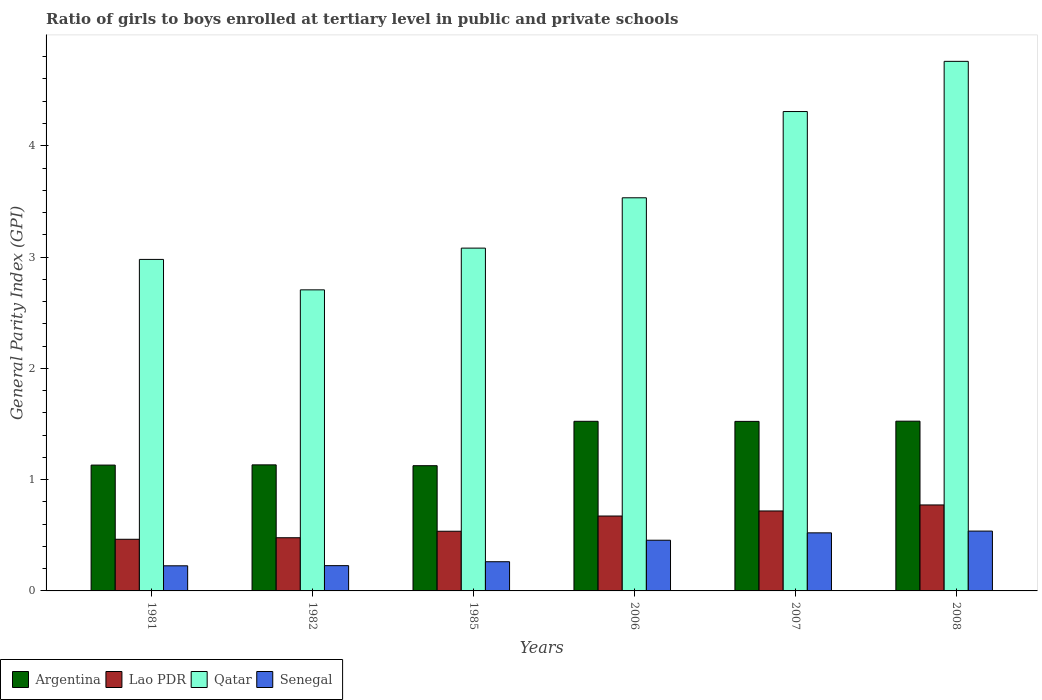How many groups of bars are there?
Your response must be concise. 6. Are the number of bars per tick equal to the number of legend labels?
Make the answer very short. Yes. In how many cases, is the number of bars for a given year not equal to the number of legend labels?
Your response must be concise. 0. What is the general parity index in Lao PDR in 1981?
Keep it short and to the point. 0.46. Across all years, what is the maximum general parity index in Qatar?
Give a very brief answer. 4.76. Across all years, what is the minimum general parity index in Argentina?
Provide a short and direct response. 1.13. In which year was the general parity index in Senegal minimum?
Give a very brief answer. 1981. What is the total general parity index in Lao PDR in the graph?
Provide a short and direct response. 3.64. What is the difference between the general parity index in Lao PDR in 1981 and that in 1985?
Your answer should be very brief. -0.07. What is the difference between the general parity index in Senegal in 1981 and the general parity index in Lao PDR in 1985?
Ensure brevity in your answer.  -0.31. What is the average general parity index in Qatar per year?
Your answer should be compact. 3.56. In the year 1985, what is the difference between the general parity index in Lao PDR and general parity index in Senegal?
Your response must be concise. 0.27. In how many years, is the general parity index in Senegal greater than 3?
Offer a very short reply. 0. What is the ratio of the general parity index in Argentina in 1981 to that in 2006?
Offer a terse response. 0.74. Is the general parity index in Senegal in 1982 less than that in 1985?
Provide a succinct answer. Yes. What is the difference between the highest and the second highest general parity index in Senegal?
Give a very brief answer. 0.02. What is the difference between the highest and the lowest general parity index in Lao PDR?
Offer a terse response. 0.31. In how many years, is the general parity index in Qatar greater than the average general parity index in Qatar taken over all years?
Your response must be concise. 2. Is the sum of the general parity index in Lao PDR in 2007 and 2008 greater than the maximum general parity index in Senegal across all years?
Give a very brief answer. Yes. Is it the case that in every year, the sum of the general parity index in Senegal and general parity index in Lao PDR is greater than the sum of general parity index in Qatar and general parity index in Argentina?
Your answer should be very brief. No. What does the 2nd bar from the left in 1981 represents?
Keep it short and to the point. Lao PDR. What does the 3rd bar from the right in 1982 represents?
Give a very brief answer. Lao PDR. How many years are there in the graph?
Keep it short and to the point. 6. Does the graph contain any zero values?
Keep it short and to the point. No. Does the graph contain grids?
Make the answer very short. No. Where does the legend appear in the graph?
Provide a succinct answer. Bottom left. What is the title of the graph?
Give a very brief answer. Ratio of girls to boys enrolled at tertiary level in public and private schools. Does "Myanmar" appear as one of the legend labels in the graph?
Offer a terse response. No. What is the label or title of the X-axis?
Ensure brevity in your answer.  Years. What is the label or title of the Y-axis?
Your answer should be very brief. General Parity Index (GPI). What is the General Parity Index (GPI) in Argentina in 1981?
Provide a short and direct response. 1.13. What is the General Parity Index (GPI) of Lao PDR in 1981?
Provide a short and direct response. 0.46. What is the General Parity Index (GPI) of Qatar in 1981?
Make the answer very short. 2.98. What is the General Parity Index (GPI) in Senegal in 1981?
Ensure brevity in your answer.  0.23. What is the General Parity Index (GPI) in Argentina in 1982?
Provide a short and direct response. 1.13. What is the General Parity Index (GPI) of Lao PDR in 1982?
Your response must be concise. 0.48. What is the General Parity Index (GPI) of Qatar in 1982?
Ensure brevity in your answer.  2.71. What is the General Parity Index (GPI) of Senegal in 1982?
Give a very brief answer. 0.23. What is the General Parity Index (GPI) in Argentina in 1985?
Keep it short and to the point. 1.13. What is the General Parity Index (GPI) in Lao PDR in 1985?
Make the answer very short. 0.54. What is the General Parity Index (GPI) of Qatar in 1985?
Make the answer very short. 3.08. What is the General Parity Index (GPI) of Senegal in 1985?
Give a very brief answer. 0.26. What is the General Parity Index (GPI) of Argentina in 2006?
Make the answer very short. 1.52. What is the General Parity Index (GPI) of Lao PDR in 2006?
Offer a terse response. 0.67. What is the General Parity Index (GPI) of Qatar in 2006?
Your answer should be compact. 3.53. What is the General Parity Index (GPI) of Senegal in 2006?
Make the answer very short. 0.46. What is the General Parity Index (GPI) in Argentina in 2007?
Give a very brief answer. 1.52. What is the General Parity Index (GPI) in Lao PDR in 2007?
Offer a very short reply. 0.72. What is the General Parity Index (GPI) in Qatar in 2007?
Ensure brevity in your answer.  4.31. What is the General Parity Index (GPI) in Senegal in 2007?
Offer a very short reply. 0.52. What is the General Parity Index (GPI) of Argentina in 2008?
Offer a terse response. 1.53. What is the General Parity Index (GPI) of Lao PDR in 2008?
Make the answer very short. 0.77. What is the General Parity Index (GPI) of Qatar in 2008?
Offer a terse response. 4.76. What is the General Parity Index (GPI) of Senegal in 2008?
Your answer should be very brief. 0.54. Across all years, what is the maximum General Parity Index (GPI) in Argentina?
Your answer should be very brief. 1.53. Across all years, what is the maximum General Parity Index (GPI) in Lao PDR?
Keep it short and to the point. 0.77. Across all years, what is the maximum General Parity Index (GPI) of Qatar?
Offer a very short reply. 4.76. Across all years, what is the maximum General Parity Index (GPI) of Senegal?
Your answer should be compact. 0.54. Across all years, what is the minimum General Parity Index (GPI) of Argentina?
Your answer should be very brief. 1.13. Across all years, what is the minimum General Parity Index (GPI) of Lao PDR?
Your response must be concise. 0.46. Across all years, what is the minimum General Parity Index (GPI) of Qatar?
Provide a succinct answer. 2.71. Across all years, what is the minimum General Parity Index (GPI) of Senegal?
Offer a very short reply. 0.23. What is the total General Parity Index (GPI) in Argentina in the graph?
Provide a short and direct response. 7.96. What is the total General Parity Index (GPI) in Lao PDR in the graph?
Give a very brief answer. 3.64. What is the total General Parity Index (GPI) in Qatar in the graph?
Your answer should be compact. 21.36. What is the total General Parity Index (GPI) of Senegal in the graph?
Offer a very short reply. 2.23. What is the difference between the General Parity Index (GPI) of Argentina in 1981 and that in 1982?
Your answer should be very brief. -0. What is the difference between the General Parity Index (GPI) of Lao PDR in 1981 and that in 1982?
Provide a short and direct response. -0.01. What is the difference between the General Parity Index (GPI) of Qatar in 1981 and that in 1982?
Offer a terse response. 0.27. What is the difference between the General Parity Index (GPI) in Senegal in 1981 and that in 1982?
Keep it short and to the point. -0. What is the difference between the General Parity Index (GPI) of Argentina in 1981 and that in 1985?
Give a very brief answer. 0.01. What is the difference between the General Parity Index (GPI) of Lao PDR in 1981 and that in 1985?
Your answer should be compact. -0.07. What is the difference between the General Parity Index (GPI) in Qatar in 1981 and that in 1985?
Make the answer very short. -0.1. What is the difference between the General Parity Index (GPI) of Senegal in 1981 and that in 1985?
Make the answer very short. -0.04. What is the difference between the General Parity Index (GPI) of Argentina in 1981 and that in 2006?
Ensure brevity in your answer.  -0.39. What is the difference between the General Parity Index (GPI) in Lao PDR in 1981 and that in 2006?
Offer a terse response. -0.21. What is the difference between the General Parity Index (GPI) in Qatar in 1981 and that in 2006?
Your response must be concise. -0.55. What is the difference between the General Parity Index (GPI) of Senegal in 1981 and that in 2006?
Give a very brief answer. -0.23. What is the difference between the General Parity Index (GPI) in Argentina in 1981 and that in 2007?
Your answer should be very brief. -0.39. What is the difference between the General Parity Index (GPI) in Lao PDR in 1981 and that in 2007?
Make the answer very short. -0.25. What is the difference between the General Parity Index (GPI) of Qatar in 1981 and that in 2007?
Ensure brevity in your answer.  -1.33. What is the difference between the General Parity Index (GPI) of Senegal in 1981 and that in 2007?
Keep it short and to the point. -0.3. What is the difference between the General Parity Index (GPI) of Argentina in 1981 and that in 2008?
Give a very brief answer. -0.39. What is the difference between the General Parity Index (GPI) in Lao PDR in 1981 and that in 2008?
Offer a very short reply. -0.31. What is the difference between the General Parity Index (GPI) in Qatar in 1981 and that in 2008?
Give a very brief answer. -1.78. What is the difference between the General Parity Index (GPI) of Senegal in 1981 and that in 2008?
Offer a very short reply. -0.31. What is the difference between the General Parity Index (GPI) of Argentina in 1982 and that in 1985?
Your answer should be very brief. 0.01. What is the difference between the General Parity Index (GPI) of Lao PDR in 1982 and that in 1985?
Make the answer very short. -0.06. What is the difference between the General Parity Index (GPI) of Qatar in 1982 and that in 1985?
Offer a very short reply. -0.38. What is the difference between the General Parity Index (GPI) of Senegal in 1982 and that in 1985?
Ensure brevity in your answer.  -0.04. What is the difference between the General Parity Index (GPI) in Argentina in 1982 and that in 2006?
Make the answer very short. -0.39. What is the difference between the General Parity Index (GPI) of Lao PDR in 1982 and that in 2006?
Provide a short and direct response. -0.2. What is the difference between the General Parity Index (GPI) of Qatar in 1982 and that in 2006?
Your answer should be very brief. -0.83. What is the difference between the General Parity Index (GPI) of Senegal in 1982 and that in 2006?
Ensure brevity in your answer.  -0.23. What is the difference between the General Parity Index (GPI) of Argentina in 1982 and that in 2007?
Provide a succinct answer. -0.39. What is the difference between the General Parity Index (GPI) in Lao PDR in 1982 and that in 2007?
Offer a very short reply. -0.24. What is the difference between the General Parity Index (GPI) in Qatar in 1982 and that in 2007?
Provide a short and direct response. -1.6. What is the difference between the General Parity Index (GPI) in Senegal in 1982 and that in 2007?
Keep it short and to the point. -0.29. What is the difference between the General Parity Index (GPI) in Argentina in 1982 and that in 2008?
Make the answer very short. -0.39. What is the difference between the General Parity Index (GPI) of Lao PDR in 1982 and that in 2008?
Your answer should be compact. -0.29. What is the difference between the General Parity Index (GPI) in Qatar in 1982 and that in 2008?
Provide a succinct answer. -2.05. What is the difference between the General Parity Index (GPI) of Senegal in 1982 and that in 2008?
Offer a terse response. -0.31. What is the difference between the General Parity Index (GPI) of Argentina in 1985 and that in 2006?
Make the answer very short. -0.4. What is the difference between the General Parity Index (GPI) in Lao PDR in 1985 and that in 2006?
Offer a terse response. -0.14. What is the difference between the General Parity Index (GPI) of Qatar in 1985 and that in 2006?
Provide a short and direct response. -0.45. What is the difference between the General Parity Index (GPI) in Senegal in 1985 and that in 2006?
Your answer should be compact. -0.19. What is the difference between the General Parity Index (GPI) of Argentina in 1985 and that in 2007?
Your answer should be compact. -0.4. What is the difference between the General Parity Index (GPI) of Lao PDR in 1985 and that in 2007?
Provide a short and direct response. -0.18. What is the difference between the General Parity Index (GPI) of Qatar in 1985 and that in 2007?
Provide a succinct answer. -1.23. What is the difference between the General Parity Index (GPI) of Senegal in 1985 and that in 2007?
Make the answer very short. -0.26. What is the difference between the General Parity Index (GPI) in Argentina in 1985 and that in 2008?
Provide a short and direct response. -0.4. What is the difference between the General Parity Index (GPI) of Lao PDR in 1985 and that in 2008?
Offer a very short reply. -0.24. What is the difference between the General Parity Index (GPI) in Qatar in 1985 and that in 2008?
Make the answer very short. -1.68. What is the difference between the General Parity Index (GPI) in Senegal in 1985 and that in 2008?
Your response must be concise. -0.28. What is the difference between the General Parity Index (GPI) of Argentina in 2006 and that in 2007?
Your answer should be compact. 0. What is the difference between the General Parity Index (GPI) of Lao PDR in 2006 and that in 2007?
Ensure brevity in your answer.  -0.05. What is the difference between the General Parity Index (GPI) in Qatar in 2006 and that in 2007?
Offer a terse response. -0.77. What is the difference between the General Parity Index (GPI) in Senegal in 2006 and that in 2007?
Provide a short and direct response. -0.07. What is the difference between the General Parity Index (GPI) of Argentina in 2006 and that in 2008?
Give a very brief answer. -0. What is the difference between the General Parity Index (GPI) in Lao PDR in 2006 and that in 2008?
Your response must be concise. -0.1. What is the difference between the General Parity Index (GPI) of Qatar in 2006 and that in 2008?
Ensure brevity in your answer.  -1.23. What is the difference between the General Parity Index (GPI) in Senegal in 2006 and that in 2008?
Provide a short and direct response. -0.08. What is the difference between the General Parity Index (GPI) in Argentina in 2007 and that in 2008?
Keep it short and to the point. -0. What is the difference between the General Parity Index (GPI) in Lao PDR in 2007 and that in 2008?
Offer a terse response. -0.05. What is the difference between the General Parity Index (GPI) of Qatar in 2007 and that in 2008?
Ensure brevity in your answer.  -0.45. What is the difference between the General Parity Index (GPI) of Senegal in 2007 and that in 2008?
Your answer should be compact. -0.02. What is the difference between the General Parity Index (GPI) of Argentina in 1981 and the General Parity Index (GPI) of Lao PDR in 1982?
Your answer should be very brief. 0.65. What is the difference between the General Parity Index (GPI) of Argentina in 1981 and the General Parity Index (GPI) of Qatar in 1982?
Your answer should be very brief. -1.57. What is the difference between the General Parity Index (GPI) in Argentina in 1981 and the General Parity Index (GPI) in Senegal in 1982?
Your answer should be compact. 0.9. What is the difference between the General Parity Index (GPI) in Lao PDR in 1981 and the General Parity Index (GPI) in Qatar in 1982?
Make the answer very short. -2.24. What is the difference between the General Parity Index (GPI) of Lao PDR in 1981 and the General Parity Index (GPI) of Senegal in 1982?
Offer a terse response. 0.24. What is the difference between the General Parity Index (GPI) in Qatar in 1981 and the General Parity Index (GPI) in Senegal in 1982?
Provide a succinct answer. 2.75. What is the difference between the General Parity Index (GPI) in Argentina in 1981 and the General Parity Index (GPI) in Lao PDR in 1985?
Your answer should be compact. 0.59. What is the difference between the General Parity Index (GPI) in Argentina in 1981 and the General Parity Index (GPI) in Qatar in 1985?
Your answer should be very brief. -1.95. What is the difference between the General Parity Index (GPI) of Argentina in 1981 and the General Parity Index (GPI) of Senegal in 1985?
Your response must be concise. 0.87. What is the difference between the General Parity Index (GPI) of Lao PDR in 1981 and the General Parity Index (GPI) of Qatar in 1985?
Offer a terse response. -2.62. What is the difference between the General Parity Index (GPI) in Lao PDR in 1981 and the General Parity Index (GPI) in Senegal in 1985?
Provide a succinct answer. 0.2. What is the difference between the General Parity Index (GPI) of Qatar in 1981 and the General Parity Index (GPI) of Senegal in 1985?
Offer a very short reply. 2.72. What is the difference between the General Parity Index (GPI) in Argentina in 1981 and the General Parity Index (GPI) in Lao PDR in 2006?
Your answer should be compact. 0.46. What is the difference between the General Parity Index (GPI) in Argentina in 1981 and the General Parity Index (GPI) in Qatar in 2006?
Provide a succinct answer. -2.4. What is the difference between the General Parity Index (GPI) of Argentina in 1981 and the General Parity Index (GPI) of Senegal in 2006?
Offer a very short reply. 0.68. What is the difference between the General Parity Index (GPI) in Lao PDR in 1981 and the General Parity Index (GPI) in Qatar in 2006?
Your answer should be very brief. -3.07. What is the difference between the General Parity Index (GPI) of Lao PDR in 1981 and the General Parity Index (GPI) of Senegal in 2006?
Your response must be concise. 0.01. What is the difference between the General Parity Index (GPI) in Qatar in 1981 and the General Parity Index (GPI) in Senegal in 2006?
Provide a short and direct response. 2.52. What is the difference between the General Parity Index (GPI) of Argentina in 1981 and the General Parity Index (GPI) of Lao PDR in 2007?
Provide a succinct answer. 0.41. What is the difference between the General Parity Index (GPI) of Argentina in 1981 and the General Parity Index (GPI) of Qatar in 2007?
Offer a terse response. -3.18. What is the difference between the General Parity Index (GPI) in Argentina in 1981 and the General Parity Index (GPI) in Senegal in 2007?
Offer a terse response. 0.61. What is the difference between the General Parity Index (GPI) of Lao PDR in 1981 and the General Parity Index (GPI) of Qatar in 2007?
Your answer should be very brief. -3.84. What is the difference between the General Parity Index (GPI) of Lao PDR in 1981 and the General Parity Index (GPI) of Senegal in 2007?
Your response must be concise. -0.06. What is the difference between the General Parity Index (GPI) of Qatar in 1981 and the General Parity Index (GPI) of Senegal in 2007?
Offer a terse response. 2.46. What is the difference between the General Parity Index (GPI) in Argentina in 1981 and the General Parity Index (GPI) in Lao PDR in 2008?
Ensure brevity in your answer.  0.36. What is the difference between the General Parity Index (GPI) of Argentina in 1981 and the General Parity Index (GPI) of Qatar in 2008?
Your answer should be very brief. -3.63. What is the difference between the General Parity Index (GPI) in Argentina in 1981 and the General Parity Index (GPI) in Senegal in 2008?
Provide a succinct answer. 0.59. What is the difference between the General Parity Index (GPI) in Lao PDR in 1981 and the General Parity Index (GPI) in Qatar in 2008?
Your response must be concise. -4.29. What is the difference between the General Parity Index (GPI) of Lao PDR in 1981 and the General Parity Index (GPI) of Senegal in 2008?
Provide a short and direct response. -0.07. What is the difference between the General Parity Index (GPI) of Qatar in 1981 and the General Parity Index (GPI) of Senegal in 2008?
Ensure brevity in your answer.  2.44. What is the difference between the General Parity Index (GPI) of Argentina in 1982 and the General Parity Index (GPI) of Lao PDR in 1985?
Your answer should be compact. 0.6. What is the difference between the General Parity Index (GPI) in Argentina in 1982 and the General Parity Index (GPI) in Qatar in 1985?
Your answer should be compact. -1.95. What is the difference between the General Parity Index (GPI) of Argentina in 1982 and the General Parity Index (GPI) of Senegal in 1985?
Your answer should be very brief. 0.87. What is the difference between the General Parity Index (GPI) in Lao PDR in 1982 and the General Parity Index (GPI) in Qatar in 1985?
Give a very brief answer. -2.6. What is the difference between the General Parity Index (GPI) of Lao PDR in 1982 and the General Parity Index (GPI) of Senegal in 1985?
Your answer should be compact. 0.22. What is the difference between the General Parity Index (GPI) in Qatar in 1982 and the General Parity Index (GPI) in Senegal in 1985?
Your answer should be compact. 2.44. What is the difference between the General Parity Index (GPI) of Argentina in 1982 and the General Parity Index (GPI) of Lao PDR in 2006?
Keep it short and to the point. 0.46. What is the difference between the General Parity Index (GPI) in Argentina in 1982 and the General Parity Index (GPI) in Qatar in 2006?
Provide a short and direct response. -2.4. What is the difference between the General Parity Index (GPI) of Argentina in 1982 and the General Parity Index (GPI) of Senegal in 2006?
Your response must be concise. 0.68. What is the difference between the General Parity Index (GPI) in Lao PDR in 1982 and the General Parity Index (GPI) in Qatar in 2006?
Make the answer very short. -3.05. What is the difference between the General Parity Index (GPI) in Lao PDR in 1982 and the General Parity Index (GPI) in Senegal in 2006?
Provide a short and direct response. 0.02. What is the difference between the General Parity Index (GPI) of Qatar in 1982 and the General Parity Index (GPI) of Senegal in 2006?
Offer a very short reply. 2.25. What is the difference between the General Parity Index (GPI) in Argentina in 1982 and the General Parity Index (GPI) in Lao PDR in 2007?
Provide a succinct answer. 0.41. What is the difference between the General Parity Index (GPI) in Argentina in 1982 and the General Parity Index (GPI) in Qatar in 2007?
Offer a very short reply. -3.17. What is the difference between the General Parity Index (GPI) in Argentina in 1982 and the General Parity Index (GPI) in Senegal in 2007?
Your response must be concise. 0.61. What is the difference between the General Parity Index (GPI) of Lao PDR in 1982 and the General Parity Index (GPI) of Qatar in 2007?
Give a very brief answer. -3.83. What is the difference between the General Parity Index (GPI) in Lao PDR in 1982 and the General Parity Index (GPI) in Senegal in 2007?
Keep it short and to the point. -0.04. What is the difference between the General Parity Index (GPI) of Qatar in 1982 and the General Parity Index (GPI) of Senegal in 2007?
Keep it short and to the point. 2.18. What is the difference between the General Parity Index (GPI) in Argentina in 1982 and the General Parity Index (GPI) in Lao PDR in 2008?
Your answer should be compact. 0.36. What is the difference between the General Parity Index (GPI) in Argentina in 1982 and the General Parity Index (GPI) in Qatar in 2008?
Offer a terse response. -3.63. What is the difference between the General Parity Index (GPI) in Argentina in 1982 and the General Parity Index (GPI) in Senegal in 2008?
Offer a very short reply. 0.6. What is the difference between the General Parity Index (GPI) in Lao PDR in 1982 and the General Parity Index (GPI) in Qatar in 2008?
Provide a short and direct response. -4.28. What is the difference between the General Parity Index (GPI) of Lao PDR in 1982 and the General Parity Index (GPI) of Senegal in 2008?
Your answer should be very brief. -0.06. What is the difference between the General Parity Index (GPI) in Qatar in 1982 and the General Parity Index (GPI) in Senegal in 2008?
Ensure brevity in your answer.  2.17. What is the difference between the General Parity Index (GPI) of Argentina in 1985 and the General Parity Index (GPI) of Lao PDR in 2006?
Offer a terse response. 0.45. What is the difference between the General Parity Index (GPI) in Argentina in 1985 and the General Parity Index (GPI) in Qatar in 2006?
Your answer should be compact. -2.41. What is the difference between the General Parity Index (GPI) of Argentina in 1985 and the General Parity Index (GPI) of Senegal in 2006?
Keep it short and to the point. 0.67. What is the difference between the General Parity Index (GPI) in Lao PDR in 1985 and the General Parity Index (GPI) in Qatar in 2006?
Keep it short and to the point. -3. What is the difference between the General Parity Index (GPI) in Lao PDR in 1985 and the General Parity Index (GPI) in Senegal in 2006?
Offer a very short reply. 0.08. What is the difference between the General Parity Index (GPI) of Qatar in 1985 and the General Parity Index (GPI) of Senegal in 2006?
Provide a short and direct response. 2.62. What is the difference between the General Parity Index (GPI) in Argentina in 1985 and the General Parity Index (GPI) in Lao PDR in 2007?
Your answer should be compact. 0.41. What is the difference between the General Parity Index (GPI) in Argentina in 1985 and the General Parity Index (GPI) in Qatar in 2007?
Your answer should be compact. -3.18. What is the difference between the General Parity Index (GPI) of Argentina in 1985 and the General Parity Index (GPI) of Senegal in 2007?
Provide a succinct answer. 0.6. What is the difference between the General Parity Index (GPI) of Lao PDR in 1985 and the General Parity Index (GPI) of Qatar in 2007?
Make the answer very short. -3.77. What is the difference between the General Parity Index (GPI) in Lao PDR in 1985 and the General Parity Index (GPI) in Senegal in 2007?
Your answer should be very brief. 0.01. What is the difference between the General Parity Index (GPI) in Qatar in 1985 and the General Parity Index (GPI) in Senegal in 2007?
Offer a very short reply. 2.56. What is the difference between the General Parity Index (GPI) in Argentina in 1985 and the General Parity Index (GPI) in Lao PDR in 2008?
Provide a short and direct response. 0.35. What is the difference between the General Parity Index (GPI) of Argentina in 1985 and the General Parity Index (GPI) of Qatar in 2008?
Offer a very short reply. -3.63. What is the difference between the General Parity Index (GPI) in Argentina in 1985 and the General Parity Index (GPI) in Senegal in 2008?
Your answer should be very brief. 0.59. What is the difference between the General Parity Index (GPI) of Lao PDR in 1985 and the General Parity Index (GPI) of Qatar in 2008?
Keep it short and to the point. -4.22. What is the difference between the General Parity Index (GPI) in Lao PDR in 1985 and the General Parity Index (GPI) in Senegal in 2008?
Your response must be concise. -0. What is the difference between the General Parity Index (GPI) of Qatar in 1985 and the General Parity Index (GPI) of Senegal in 2008?
Keep it short and to the point. 2.54. What is the difference between the General Parity Index (GPI) of Argentina in 2006 and the General Parity Index (GPI) of Lao PDR in 2007?
Give a very brief answer. 0.81. What is the difference between the General Parity Index (GPI) in Argentina in 2006 and the General Parity Index (GPI) in Qatar in 2007?
Your answer should be compact. -2.78. What is the difference between the General Parity Index (GPI) in Argentina in 2006 and the General Parity Index (GPI) in Senegal in 2007?
Offer a very short reply. 1. What is the difference between the General Parity Index (GPI) of Lao PDR in 2006 and the General Parity Index (GPI) of Qatar in 2007?
Keep it short and to the point. -3.63. What is the difference between the General Parity Index (GPI) of Lao PDR in 2006 and the General Parity Index (GPI) of Senegal in 2007?
Offer a terse response. 0.15. What is the difference between the General Parity Index (GPI) in Qatar in 2006 and the General Parity Index (GPI) in Senegal in 2007?
Offer a terse response. 3.01. What is the difference between the General Parity Index (GPI) of Argentina in 2006 and the General Parity Index (GPI) of Lao PDR in 2008?
Offer a very short reply. 0.75. What is the difference between the General Parity Index (GPI) of Argentina in 2006 and the General Parity Index (GPI) of Qatar in 2008?
Keep it short and to the point. -3.23. What is the difference between the General Parity Index (GPI) of Argentina in 2006 and the General Parity Index (GPI) of Senegal in 2008?
Keep it short and to the point. 0.99. What is the difference between the General Parity Index (GPI) of Lao PDR in 2006 and the General Parity Index (GPI) of Qatar in 2008?
Your response must be concise. -4.09. What is the difference between the General Parity Index (GPI) in Lao PDR in 2006 and the General Parity Index (GPI) in Senegal in 2008?
Your answer should be compact. 0.14. What is the difference between the General Parity Index (GPI) in Qatar in 2006 and the General Parity Index (GPI) in Senegal in 2008?
Make the answer very short. 2.99. What is the difference between the General Parity Index (GPI) in Argentina in 2007 and the General Parity Index (GPI) in Lao PDR in 2008?
Make the answer very short. 0.75. What is the difference between the General Parity Index (GPI) of Argentina in 2007 and the General Parity Index (GPI) of Qatar in 2008?
Give a very brief answer. -3.24. What is the difference between the General Parity Index (GPI) of Argentina in 2007 and the General Parity Index (GPI) of Senegal in 2008?
Keep it short and to the point. 0.99. What is the difference between the General Parity Index (GPI) in Lao PDR in 2007 and the General Parity Index (GPI) in Qatar in 2008?
Provide a short and direct response. -4.04. What is the difference between the General Parity Index (GPI) of Lao PDR in 2007 and the General Parity Index (GPI) of Senegal in 2008?
Your response must be concise. 0.18. What is the difference between the General Parity Index (GPI) of Qatar in 2007 and the General Parity Index (GPI) of Senegal in 2008?
Make the answer very short. 3.77. What is the average General Parity Index (GPI) in Argentina per year?
Your response must be concise. 1.33. What is the average General Parity Index (GPI) of Lao PDR per year?
Ensure brevity in your answer.  0.61. What is the average General Parity Index (GPI) of Qatar per year?
Make the answer very short. 3.56. What is the average General Parity Index (GPI) in Senegal per year?
Your answer should be very brief. 0.37. In the year 1981, what is the difference between the General Parity Index (GPI) of Argentina and General Parity Index (GPI) of Lao PDR?
Give a very brief answer. 0.67. In the year 1981, what is the difference between the General Parity Index (GPI) in Argentina and General Parity Index (GPI) in Qatar?
Your response must be concise. -1.85. In the year 1981, what is the difference between the General Parity Index (GPI) of Argentina and General Parity Index (GPI) of Senegal?
Your answer should be compact. 0.91. In the year 1981, what is the difference between the General Parity Index (GPI) of Lao PDR and General Parity Index (GPI) of Qatar?
Offer a terse response. -2.51. In the year 1981, what is the difference between the General Parity Index (GPI) in Lao PDR and General Parity Index (GPI) in Senegal?
Your response must be concise. 0.24. In the year 1981, what is the difference between the General Parity Index (GPI) in Qatar and General Parity Index (GPI) in Senegal?
Ensure brevity in your answer.  2.75. In the year 1982, what is the difference between the General Parity Index (GPI) in Argentina and General Parity Index (GPI) in Lao PDR?
Your response must be concise. 0.65. In the year 1982, what is the difference between the General Parity Index (GPI) in Argentina and General Parity Index (GPI) in Qatar?
Ensure brevity in your answer.  -1.57. In the year 1982, what is the difference between the General Parity Index (GPI) in Argentina and General Parity Index (GPI) in Senegal?
Provide a succinct answer. 0.91. In the year 1982, what is the difference between the General Parity Index (GPI) of Lao PDR and General Parity Index (GPI) of Qatar?
Offer a terse response. -2.23. In the year 1982, what is the difference between the General Parity Index (GPI) in Lao PDR and General Parity Index (GPI) in Senegal?
Give a very brief answer. 0.25. In the year 1982, what is the difference between the General Parity Index (GPI) in Qatar and General Parity Index (GPI) in Senegal?
Keep it short and to the point. 2.48. In the year 1985, what is the difference between the General Parity Index (GPI) of Argentina and General Parity Index (GPI) of Lao PDR?
Give a very brief answer. 0.59. In the year 1985, what is the difference between the General Parity Index (GPI) in Argentina and General Parity Index (GPI) in Qatar?
Offer a very short reply. -1.96. In the year 1985, what is the difference between the General Parity Index (GPI) of Argentina and General Parity Index (GPI) of Senegal?
Keep it short and to the point. 0.86. In the year 1985, what is the difference between the General Parity Index (GPI) of Lao PDR and General Parity Index (GPI) of Qatar?
Keep it short and to the point. -2.54. In the year 1985, what is the difference between the General Parity Index (GPI) of Lao PDR and General Parity Index (GPI) of Senegal?
Give a very brief answer. 0.27. In the year 1985, what is the difference between the General Parity Index (GPI) of Qatar and General Parity Index (GPI) of Senegal?
Keep it short and to the point. 2.82. In the year 2006, what is the difference between the General Parity Index (GPI) in Argentina and General Parity Index (GPI) in Lao PDR?
Provide a succinct answer. 0.85. In the year 2006, what is the difference between the General Parity Index (GPI) of Argentina and General Parity Index (GPI) of Qatar?
Your answer should be very brief. -2.01. In the year 2006, what is the difference between the General Parity Index (GPI) in Argentina and General Parity Index (GPI) in Senegal?
Provide a succinct answer. 1.07. In the year 2006, what is the difference between the General Parity Index (GPI) in Lao PDR and General Parity Index (GPI) in Qatar?
Your response must be concise. -2.86. In the year 2006, what is the difference between the General Parity Index (GPI) of Lao PDR and General Parity Index (GPI) of Senegal?
Provide a short and direct response. 0.22. In the year 2006, what is the difference between the General Parity Index (GPI) of Qatar and General Parity Index (GPI) of Senegal?
Your answer should be compact. 3.08. In the year 2007, what is the difference between the General Parity Index (GPI) in Argentina and General Parity Index (GPI) in Lao PDR?
Offer a very short reply. 0.8. In the year 2007, what is the difference between the General Parity Index (GPI) in Argentina and General Parity Index (GPI) in Qatar?
Your response must be concise. -2.78. In the year 2007, what is the difference between the General Parity Index (GPI) in Lao PDR and General Parity Index (GPI) in Qatar?
Keep it short and to the point. -3.59. In the year 2007, what is the difference between the General Parity Index (GPI) of Lao PDR and General Parity Index (GPI) of Senegal?
Your response must be concise. 0.2. In the year 2007, what is the difference between the General Parity Index (GPI) in Qatar and General Parity Index (GPI) in Senegal?
Offer a terse response. 3.79. In the year 2008, what is the difference between the General Parity Index (GPI) of Argentina and General Parity Index (GPI) of Lao PDR?
Keep it short and to the point. 0.75. In the year 2008, what is the difference between the General Parity Index (GPI) of Argentina and General Parity Index (GPI) of Qatar?
Make the answer very short. -3.23. In the year 2008, what is the difference between the General Parity Index (GPI) in Argentina and General Parity Index (GPI) in Senegal?
Provide a short and direct response. 0.99. In the year 2008, what is the difference between the General Parity Index (GPI) of Lao PDR and General Parity Index (GPI) of Qatar?
Your response must be concise. -3.99. In the year 2008, what is the difference between the General Parity Index (GPI) of Lao PDR and General Parity Index (GPI) of Senegal?
Ensure brevity in your answer.  0.23. In the year 2008, what is the difference between the General Parity Index (GPI) in Qatar and General Parity Index (GPI) in Senegal?
Your answer should be very brief. 4.22. What is the ratio of the General Parity Index (GPI) of Argentina in 1981 to that in 1982?
Give a very brief answer. 1. What is the ratio of the General Parity Index (GPI) in Lao PDR in 1981 to that in 1982?
Ensure brevity in your answer.  0.97. What is the ratio of the General Parity Index (GPI) in Qatar in 1981 to that in 1982?
Your answer should be compact. 1.1. What is the ratio of the General Parity Index (GPI) in Argentina in 1981 to that in 1985?
Offer a terse response. 1. What is the ratio of the General Parity Index (GPI) in Lao PDR in 1981 to that in 1985?
Your response must be concise. 0.87. What is the ratio of the General Parity Index (GPI) in Qatar in 1981 to that in 1985?
Your response must be concise. 0.97. What is the ratio of the General Parity Index (GPI) in Senegal in 1981 to that in 1985?
Provide a succinct answer. 0.86. What is the ratio of the General Parity Index (GPI) in Argentina in 1981 to that in 2006?
Keep it short and to the point. 0.74. What is the ratio of the General Parity Index (GPI) of Lao PDR in 1981 to that in 2006?
Keep it short and to the point. 0.69. What is the ratio of the General Parity Index (GPI) of Qatar in 1981 to that in 2006?
Keep it short and to the point. 0.84. What is the ratio of the General Parity Index (GPI) in Senegal in 1981 to that in 2006?
Offer a very short reply. 0.5. What is the ratio of the General Parity Index (GPI) in Argentina in 1981 to that in 2007?
Make the answer very short. 0.74. What is the ratio of the General Parity Index (GPI) in Lao PDR in 1981 to that in 2007?
Your answer should be very brief. 0.65. What is the ratio of the General Parity Index (GPI) of Qatar in 1981 to that in 2007?
Offer a very short reply. 0.69. What is the ratio of the General Parity Index (GPI) of Senegal in 1981 to that in 2007?
Offer a very short reply. 0.43. What is the ratio of the General Parity Index (GPI) in Argentina in 1981 to that in 2008?
Keep it short and to the point. 0.74. What is the ratio of the General Parity Index (GPI) of Lao PDR in 1981 to that in 2008?
Offer a terse response. 0.6. What is the ratio of the General Parity Index (GPI) of Qatar in 1981 to that in 2008?
Offer a terse response. 0.63. What is the ratio of the General Parity Index (GPI) of Senegal in 1981 to that in 2008?
Keep it short and to the point. 0.42. What is the ratio of the General Parity Index (GPI) of Argentina in 1982 to that in 1985?
Offer a very short reply. 1.01. What is the ratio of the General Parity Index (GPI) in Lao PDR in 1982 to that in 1985?
Provide a short and direct response. 0.89. What is the ratio of the General Parity Index (GPI) in Qatar in 1982 to that in 1985?
Offer a very short reply. 0.88. What is the ratio of the General Parity Index (GPI) of Senegal in 1982 to that in 1985?
Your answer should be compact. 0.87. What is the ratio of the General Parity Index (GPI) in Argentina in 1982 to that in 2006?
Provide a short and direct response. 0.74. What is the ratio of the General Parity Index (GPI) in Lao PDR in 1982 to that in 2006?
Keep it short and to the point. 0.71. What is the ratio of the General Parity Index (GPI) of Qatar in 1982 to that in 2006?
Ensure brevity in your answer.  0.77. What is the ratio of the General Parity Index (GPI) of Senegal in 1982 to that in 2006?
Provide a succinct answer. 0.5. What is the ratio of the General Parity Index (GPI) of Argentina in 1982 to that in 2007?
Give a very brief answer. 0.74. What is the ratio of the General Parity Index (GPI) in Lao PDR in 1982 to that in 2007?
Make the answer very short. 0.67. What is the ratio of the General Parity Index (GPI) in Qatar in 1982 to that in 2007?
Offer a very short reply. 0.63. What is the ratio of the General Parity Index (GPI) of Senegal in 1982 to that in 2007?
Provide a short and direct response. 0.44. What is the ratio of the General Parity Index (GPI) of Argentina in 1982 to that in 2008?
Offer a terse response. 0.74. What is the ratio of the General Parity Index (GPI) in Lao PDR in 1982 to that in 2008?
Provide a succinct answer. 0.62. What is the ratio of the General Parity Index (GPI) of Qatar in 1982 to that in 2008?
Offer a very short reply. 0.57. What is the ratio of the General Parity Index (GPI) in Senegal in 1982 to that in 2008?
Provide a short and direct response. 0.42. What is the ratio of the General Parity Index (GPI) in Argentina in 1985 to that in 2006?
Keep it short and to the point. 0.74. What is the ratio of the General Parity Index (GPI) of Lao PDR in 1985 to that in 2006?
Give a very brief answer. 0.8. What is the ratio of the General Parity Index (GPI) of Qatar in 1985 to that in 2006?
Offer a terse response. 0.87. What is the ratio of the General Parity Index (GPI) of Senegal in 1985 to that in 2006?
Offer a very short reply. 0.58. What is the ratio of the General Parity Index (GPI) of Argentina in 1985 to that in 2007?
Your answer should be compact. 0.74. What is the ratio of the General Parity Index (GPI) in Lao PDR in 1985 to that in 2007?
Your answer should be very brief. 0.75. What is the ratio of the General Parity Index (GPI) in Qatar in 1985 to that in 2007?
Keep it short and to the point. 0.72. What is the ratio of the General Parity Index (GPI) in Senegal in 1985 to that in 2007?
Ensure brevity in your answer.  0.5. What is the ratio of the General Parity Index (GPI) in Argentina in 1985 to that in 2008?
Your answer should be compact. 0.74. What is the ratio of the General Parity Index (GPI) in Lao PDR in 1985 to that in 2008?
Your answer should be very brief. 0.69. What is the ratio of the General Parity Index (GPI) in Qatar in 1985 to that in 2008?
Make the answer very short. 0.65. What is the ratio of the General Parity Index (GPI) of Senegal in 1985 to that in 2008?
Provide a short and direct response. 0.49. What is the ratio of the General Parity Index (GPI) in Lao PDR in 2006 to that in 2007?
Your answer should be very brief. 0.94. What is the ratio of the General Parity Index (GPI) of Qatar in 2006 to that in 2007?
Provide a short and direct response. 0.82. What is the ratio of the General Parity Index (GPI) of Senegal in 2006 to that in 2007?
Offer a terse response. 0.87. What is the ratio of the General Parity Index (GPI) of Argentina in 2006 to that in 2008?
Give a very brief answer. 1. What is the ratio of the General Parity Index (GPI) in Lao PDR in 2006 to that in 2008?
Make the answer very short. 0.87. What is the ratio of the General Parity Index (GPI) of Qatar in 2006 to that in 2008?
Give a very brief answer. 0.74. What is the ratio of the General Parity Index (GPI) of Senegal in 2006 to that in 2008?
Ensure brevity in your answer.  0.85. What is the ratio of the General Parity Index (GPI) in Argentina in 2007 to that in 2008?
Provide a short and direct response. 1. What is the ratio of the General Parity Index (GPI) in Lao PDR in 2007 to that in 2008?
Keep it short and to the point. 0.93. What is the ratio of the General Parity Index (GPI) in Qatar in 2007 to that in 2008?
Give a very brief answer. 0.91. What is the ratio of the General Parity Index (GPI) of Senegal in 2007 to that in 2008?
Your answer should be very brief. 0.97. What is the difference between the highest and the second highest General Parity Index (GPI) of Argentina?
Give a very brief answer. 0. What is the difference between the highest and the second highest General Parity Index (GPI) in Lao PDR?
Offer a very short reply. 0.05. What is the difference between the highest and the second highest General Parity Index (GPI) in Qatar?
Your response must be concise. 0.45. What is the difference between the highest and the second highest General Parity Index (GPI) in Senegal?
Ensure brevity in your answer.  0.02. What is the difference between the highest and the lowest General Parity Index (GPI) of Argentina?
Your response must be concise. 0.4. What is the difference between the highest and the lowest General Parity Index (GPI) of Lao PDR?
Your answer should be compact. 0.31. What is the difference between the highest and the lowest General Parity Index (GPI) in Qatar?
Provide a succinct answer. 2.05. What is the difference between the highest and the lowest General Parity Index (GPI) of Senegal?
Make the answer very short. 0.31. 